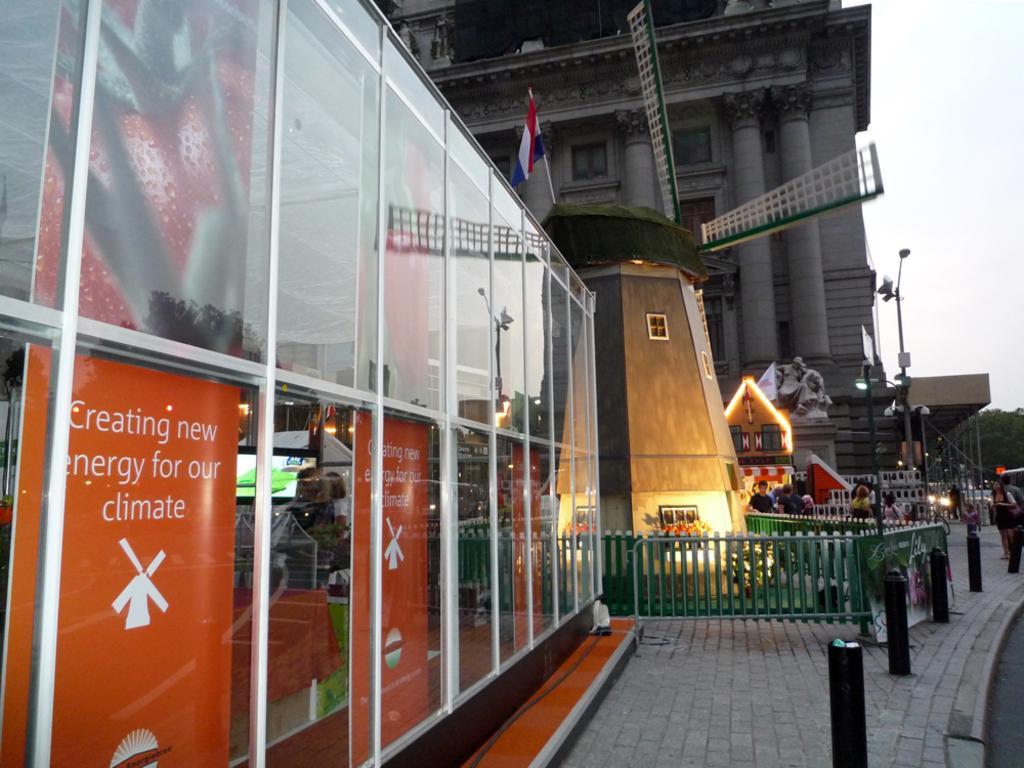In one or two sentences, can you explain what this image depicts? In this picture there is a big glass shop. Behind there is a small decorative windmill. In the front there is a green color fencing railing. In the background we can see a big white color building and some statue with flag. 